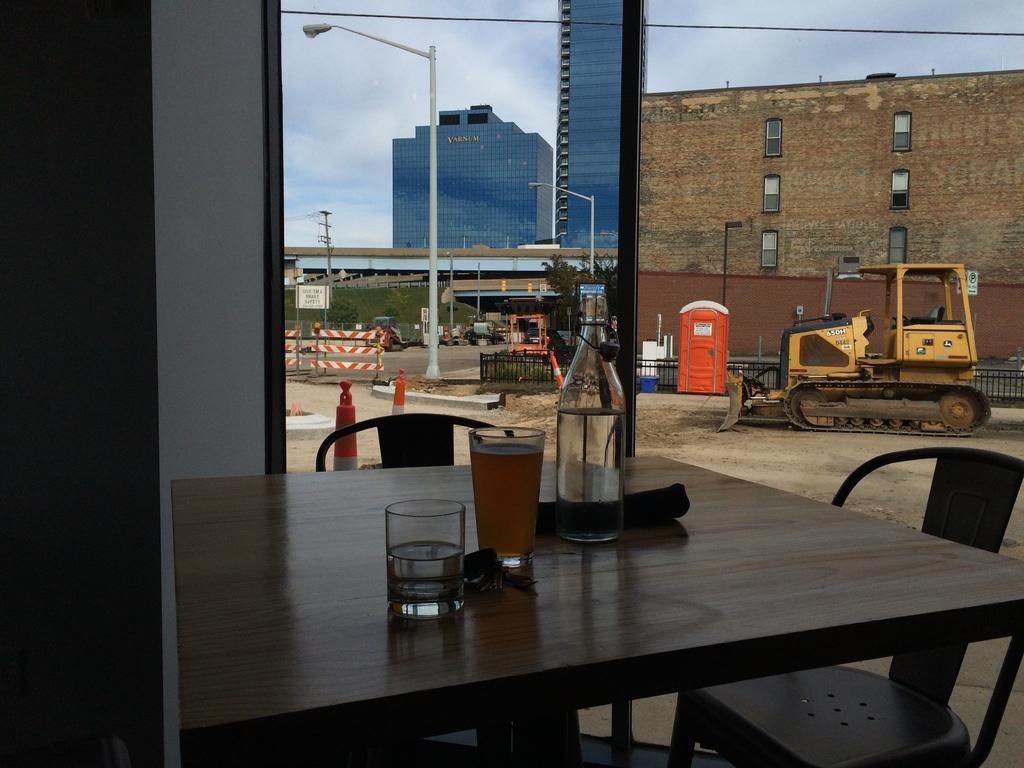Could you give a brief overview of what you see in this image? We can see table and chairs,on the table there are glasses,bottle. We can see glass window,from this glass window we can see vehicle,fence,road,pole,light,building,sky,trees. 